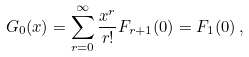Convert formula to latex. <formula><loc_0><loc_0><loc_500><loc_500>G _ { 0 } ( x ) = \sum _ { r = 0 } ^ { \infty } \frac { x ^ { r } } { r ! } F _ { r + 1 } ( 0 ) = F _ { 1 } ( 0 ) \, ,</formula> 